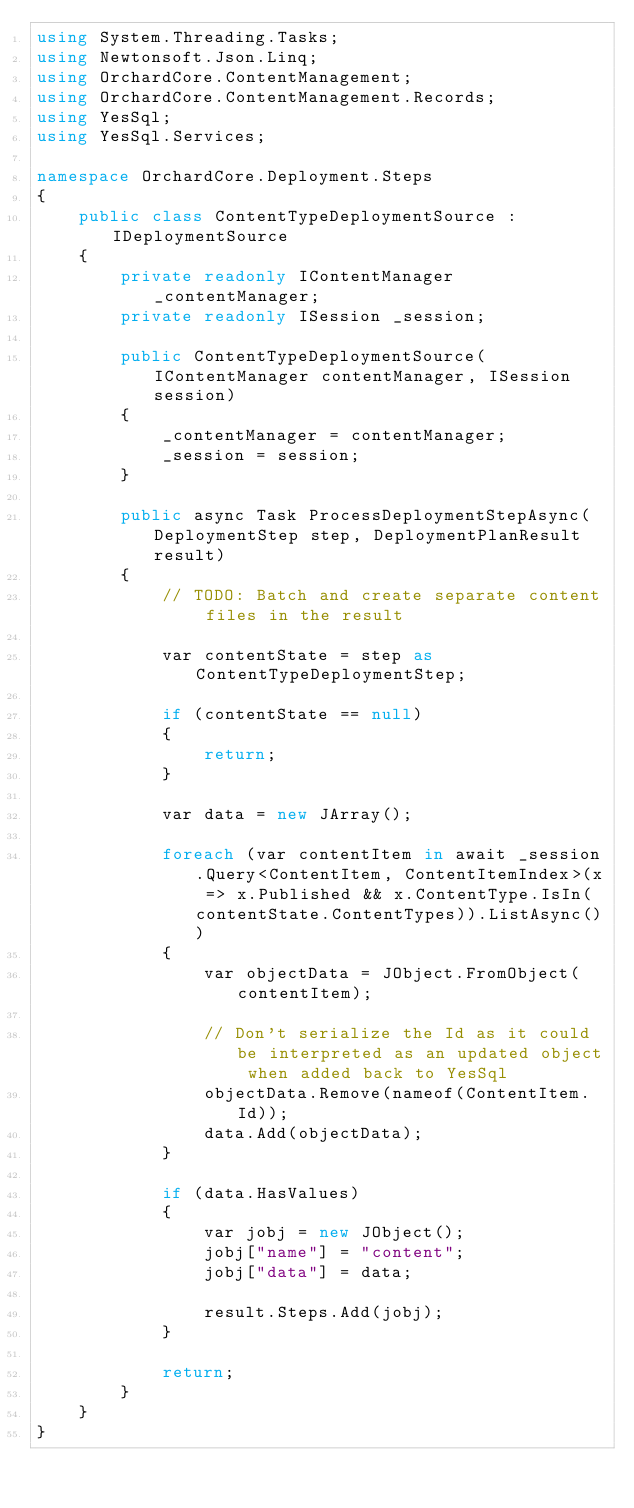<code> <loc_0><loc_0><loc_500><loc_500><_C#_>using System.Threading.Tasks;
using Newtonsoft.Json.Linq;
using OrchardCore.ContentManagement;
using OrchardCore.ContentManagement.Records;
using YesSql;
using YesSql.Services;

namespace OrchardCore.Deployment.Steps
{
    public class ContentTypeDeploymentSource : IDeploymentSource
    {
        private readonly IContentManager _contentManager;
        private readonly ISession _session;

        public ContentTypeDeploymentSource(IContentManager contentManager, ISession session)
        {
            _contentManager = contentManager;
            _session = session;
        }

        public async Task ProcessDeploymentStepAsync(DeploymentStep step, DeploymentPlanResult result)
        {
            // TODO: Batch and create separate content files in the result

            var contentState = step as ContentTypeDeploymentStep;

            if (contentState == null)
            {
                return;
            }

            var data = new JArray();

            foreach (var contentItem in await _session.Query<ContentItem, ContentItemIndex>(x => x.Published && x.ContentType.IsIn(contentState.ContentTypes)).ListAsync())
            {
                var objectData = JObject.FromObject(contentItem);

                // Don't serialize the Id as it could be interpreted as an updated object when added back to YesSql
                objectData.Remove(nameof(ContentItem.Id));
                data.Add(objectData);
            }

            if (data.HasValues)
            {
                var jobj = new JObject();
                jobj["name"] = "content";
                jobj["data"] = data;

                result.Steps.Add(jobj);
            }

            return;
        }
    }
}
</code> 